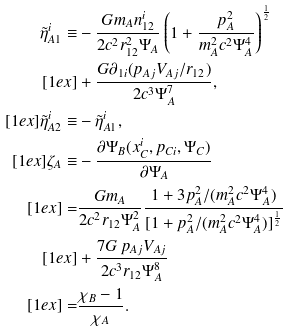Convert formula to latex. <formula><loc_0><loc_0><loc_500><loc_500>\tilde { \eta } _ { A 1 } ^ { i } \equiv & - \frac { G m _ { A } n _ { 1 2 } ^ { i } } { 2 c ^ { 2 } r _ { 1 2 } ^ { 2 } \Psi _ { A } } \left ( 1 + \frac { p _ { A } ^ { 2 } } { m _ { A } ^ { 2 } c ^ { 2 } \Psi _ { A } ^ { 4 } } \right ) ^ { \frac { 1 } { 2 } } \\ [ 1 e x ] & + \frac { G \partial _ { 1 i } ( p _ { A j } V _ { A j } / r _ { 1 2 } ) } { 2 c ^ { 3 } \Psi _ { A } ^ { 7 } } , \\ [ 1 e x ] \tilde { \eta } _ { A 2 } ^ { i } \equiv & - \tilde { \eta } _ { A 1 } ^ { i } , \\ [ 1 e x ] \zeta _ { A } \equiv & - \frac { \partial \Psi _ { B } ( x ^ { i } _ { C } , p _ { C i } , \Psi _ { C } ) } { \partial \Psi _ { A } } \\ [ 1 e x ] = & \frac { G m _ { A } } { 2 c ^ { 2 } r _ { 1 2 } \Psi _ { A } ^ { 2 } } \frac { 1 + 3 p _ { A } ^ { 2 } / ( m _ { A } ^ { 2 } c ^ { 2 } \Psi _ { A } ^ { 4 } ) } { [ 1 + p _ { A } ^ { 2 } / ( m _ { A } ^ { 2 } c ^ { 2 } \Psi _ { A } ^ { 4 } ) ] ^ { \frac { 1 } { 2 } } } \\ [ 1 e x ] & + \frac { 7 G \, p _ { A j } V _ { A j } } { 2 c ^ { 3 } r _ { 1 2 } \Psi _ { A } ^ { 8 } } \\ [ 1 e x ] = & \frac { \chi _ { B } - 1 } { \chi _ { A } } .</formula> 